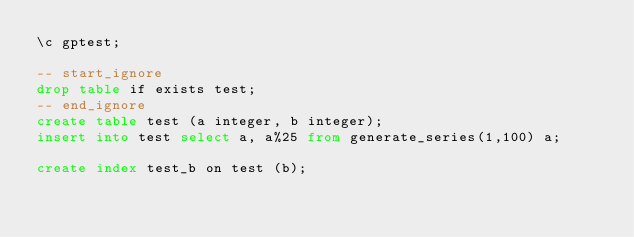Convert code to text. <code><loc_0><loc_0><loc_500><loc_500><_SQL_>\c gptest;

-- start_ignore
drop table if exists test;
-- end_ignore
create table test (a integer, b integer);
insert into test select a, a%25 from generate_series(1,100) a;

create index test_b on test (b);
</code> 